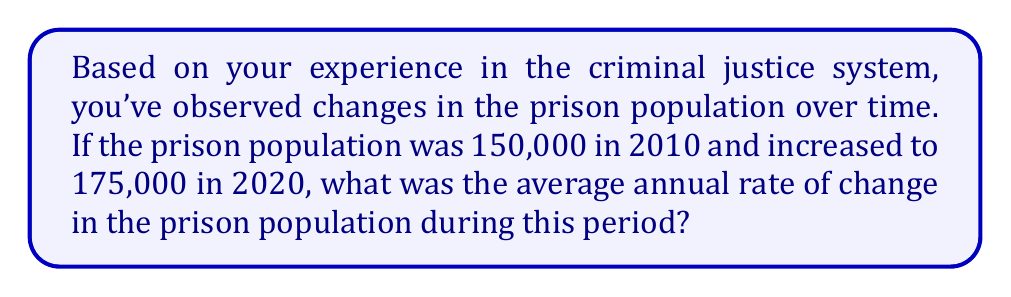Help me with this question. To find the average annual rate of change, we need to:
1. Calculate the total change in population
2. Divide this change by the number of years
3. Express the result as a rate

Step 1: Calculate the total change in population
$$\text{Total change} = \text{Final population} - \text{Initial population}$$
$$\text{Total change} = 175,000 - 150,000 = 25,000$$

Step 2: Determine the time period
The time period is from 2010 to 2020, which is 10 years.

Step 3: Calculate the average annual rate of change
$$\text{Average annual rate of change} = \frac{\text{Total change}}{\text{Number of years}}$$
$$\text{Average annual rate of change} = \frac{25,000}{10} = 2,500$$

Therefore, the average annual rate of change in the prison population was an increase of 2,500 people per year.
Answer: The average annual rate of change in the prison population from 2010 to 2020 was an increase of 2,500 people per year. 